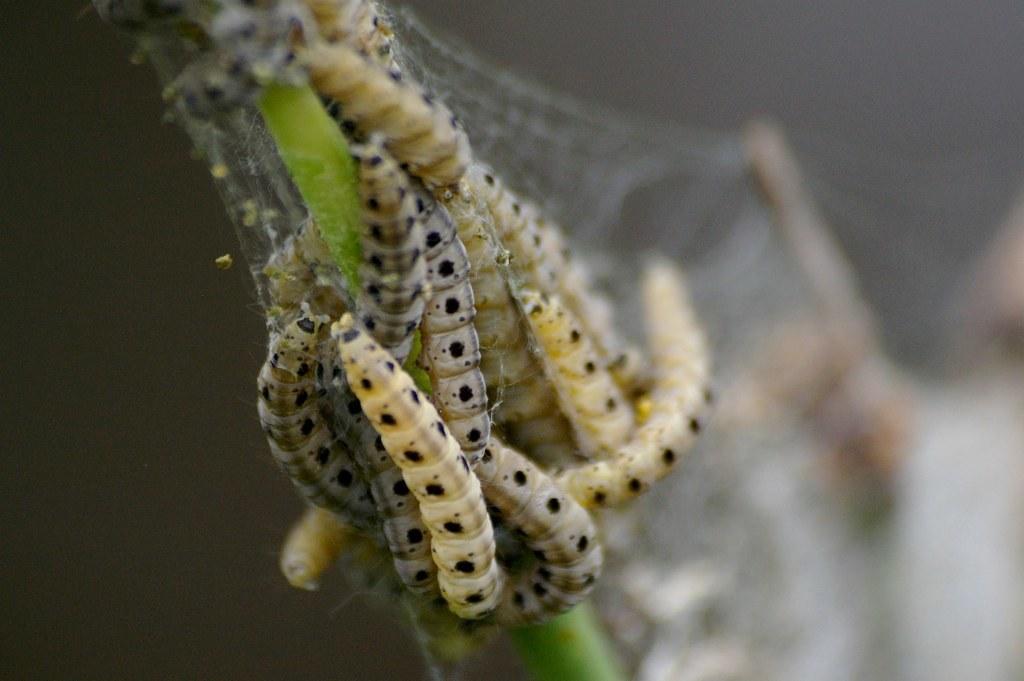In one or two sentences, can you explain what this image depicts? In this picture we can see a group of insects on a stem and in the background it is blurry. 